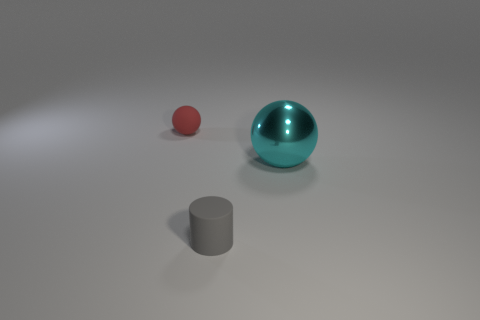The red rubber object that is the same shape as the large cyan metal object is what size?
Your response must be concise. Small. Is there anything else that has the same material as the cyan thing?
Make the answer very short. No. Are there the same number of tiny gray rubber cylinders behind the cylinder and cyan objects that are to the right of the red rubber object?
Give a very brief answer. No. There is a thing that is left of the cyan metallic ball and in front of the rubber ball; what is its material?
Your answer should be very brief. Rubber. Is the size of the red rubber thing the same as the sphere that is in front of the red rubber ball?
Give a very brief answer. No. What number of other objects are there of the same color as the big object?
Provide a succinct answer. 0. Is the number of rubber objects behind the shiny object greater than the number of large gray rubber cubes?
Your answer should be compact. Yes. What is the color of the matte thing behind the sphere that is right of the tiny object behind the cyan shiny sphere?
Ensure brevity in your answer.  Red. Is the tiny gray object made of the same material as the small red thing?
Your answer should be compact. Yes. Are there any red things of the same size as the gray rubber object?
Provide a short and direct response. Yes. 